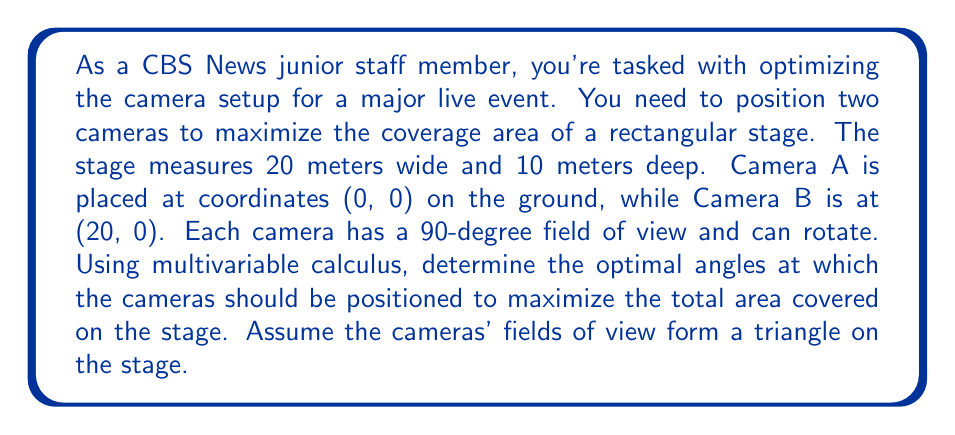Could you help me with this problem? To solve this problem, we'll use multivariable calculus to maximize the total area covered by both cameras. Let's approach this step-by-step:

1) Let $\theta_A$ and $\theta_B$ be the angles of rotation for Camera A and Camera B, respectively, measured from the stage's front edge.

2) The area covered by each camera forms a triangle. For Camera A, the triangle has a base of $20\tan(\theta_A)$ and a height of 10. For Camera B, the base is $20\tan(\theta_B)$ and the height is 10.

3) The total area covered is the sum of these two triangles:

   $$A(\theta_A, \theta_B) = \frac{1}{2} \cdot 20 \cdot 10 \cdot (\tan(\theta_A) + \tan(\theta_B))$$

4) To maximize this area, we need to find the partial derivatives with respect to $\theta_A$ and $\theta_B$ and set them to zero:

   $$\frac{\partial A}{\partial \theta_A} = 100 \cdot \sec^2(\theta_A) = 0$$
   $$\frac{\partial A}{\partial \theta_B} = 100 \cdot \sec^2(\theta_B) = 0$$

5) However, these equations are never zero for real angles. This means the maximum must occur at the boundaries of our domain.

6) Given the 90-degree field of view, the maximum possible angle for each camera is 45 degrees (half of 90 degrees).

7) Therefore, the optimal solution is to set both cameras at their maximum angle:

   $$\theta_A = \theta_B = 45°$$

8) At these angles, each camera covers half of the stage, and together they cover the entire stage without overlap.

9) We can verify this by calculating the area:

   $$A(45°, 45°) = \frac{1}{2} \cdot 20 \cdot 10 \cdot (\tan(45°) + \tan(45°))$$
   $$= 100 \cdot (1 + 1) = 200 \text{ m}^2$$

   Which is indeed the total area of the stage (20m × 10m = 200m²).
Answer: The optimal angles for the cameras are $\theta_A = \theta_B = 45°$, which results in complete coverage of the 200 m² stage area. 